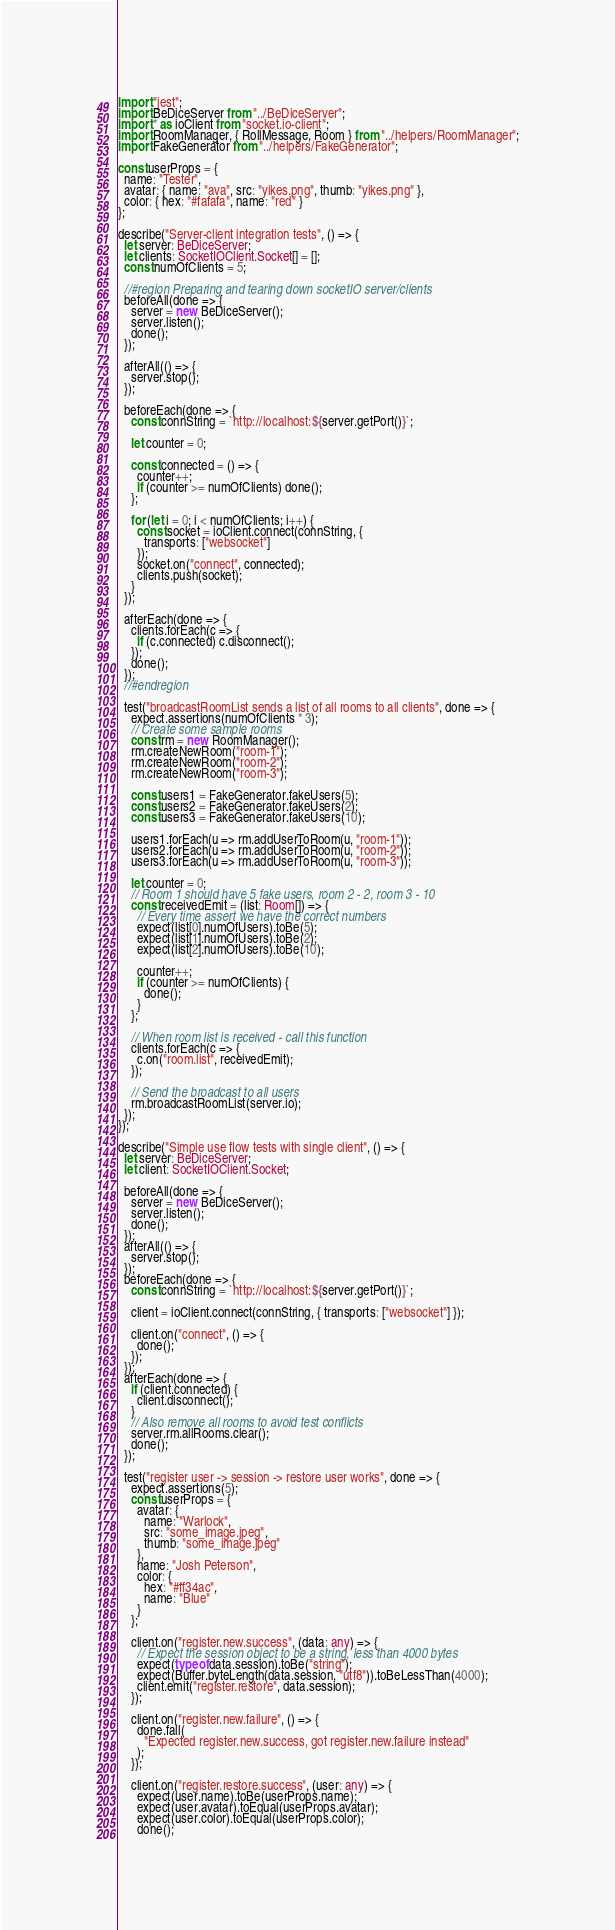<code> <loc_0><loc_0><loc_500><loc_500><_TypeScript_>import "jest";
import BeDiceServer from "../BeDiceServer";
import * as ioClient from "socket.io-client";
import RoomManager, { RollMessage, Room } from "../helpers/RoomManager";
import FakeGenerator from "../helpers/FakeGenerator";

const userProps = {
  name: "Tester",
  avatar: { name: "ava", src: "yikes.png", thumb: "yikes.png" },
  color: { hex: "#fafafa", name: "red" }
};

describe("Server-client integration tests", () => {
  let server: BeDiceServer;
  let clients: SocketIOClient.Socket[] = [];
  const numOfClients = 5;

  //#region Preparing and tearing down socketIO server/clients
  beforeAll(done => {
    server = new BeDiceServer();
    server.listen();
    done();
  });

  afterAll(() => {
    server.stop();
  });

  beforeEach(done => {
    const connString = `http://localhost:${server.getPort()}`;

    let counter = 0;

    const connected = () => {
      counter++;
      if (counter >= numOfClients) done();
    };

    for (let i = 0; i < numOfClients; i++) {
      const socket = ioClient.connect(connString, {
        transports: ["websocket"]
      });
      socket.on("connect", connected);
      clients.push(socket);
    }
  });

  afterEach(done => {
    clients.forEach(c => {
      if (c.connected) c.disconnect();
    });
    done();
  });
  //#endregion

  test("broadcastRoomList sends a list of all rooms to all clients", done => {
    expect.assertions(numOfClients * 3);
    // Create some sample rooms
    const rm = new RoomManager();
    rm.createNewRoom("room-1");
    rm.createNewRoom("room-2");
    rm.createNewRoom("room-3");

    const users1 = FakeGenerator.fakeUsers(5);
    const users2 = FakeGenerator.fakeUsers(2);
    const users3 = FakeGenerator.fakeUsers(10);

    users1.forEach(u => rm.addUserToRoom(u, "room-1"));
    users2.forEach(u => rm.addUserToRoom(u, "room-2"));
    users3.forEach(u => rm.addUserToRoom(u, "room-3"));

    let counter = 0;
    // Room 1 should have 5 fake users, room 2 - 2, room 3 - 10
    const receivedEmit = (list: Room[]) => {
      // Every time assert we have the correct numbers
      expect(list[0].numOfUsers).toBe(5);
      expect(list[1].numOfUsers).toBe(2);
      expect(list[2].numOfUsers).toBe(10);

      counter++;
      if (counter >= numOfClients) {
        done();
      }
    };

    // When room list is received - call this function
    clients.forEach(c => {
      c.on("room.list", receivedEmit);
    });

    // Send the broadcast to all users
    rm.broadcastRoomList(server.io);
  });
});

describe("Simple use flow tests with single client", () => {
  let server: BeDiceServer;
  let client: SocketIOClient.Socket;

  beforeAll(done => {
    server = new BeDiceServer();
    server.listen();
    done();
  });
  afterAll(() => {
    server.stop();
  });
  beforeEach(done => {
    const connString = `http://localhost:${server.getPort()}`;

    client = ioClient.connect(connString, { transports: ["websocket"] });

    client.on("connect", () => {
      done();
    });
  });
  afterEach(done => {
    if (client.connected) {
      client.disconnect();
    }
    // Also remove all rooms to avoid test conflicts
    server.rm.allRooms.clear();
    done();
  });

  test("register user -> session -> restore user works", done => {
    expect.assertions(5);
    const userProps = {
      avatar: {
        name: "Warlock",
        src: "some_image.jpeg",
        thumb: "some_image.jpeg"
      },
      name: "Josh Peterson",
      color: {
        hex: "#ff34ac",
        name: "Blue"
      }
    };

    client.on("register.new.success", (data: any) => {
      // Expect the session object to be a string, less than 4000 bytes
      expect(typeof data.session).toBe("string");
      expect(Buffer.byteLength(data.session, "utf8")).toBeLessThan(4000);
      client.emit("register.restore", data.session);
    });

    client.on("register.new.failure", () => {
      done.fail(
        "Expected register.new.success, got register.new.failure instead"
      );
    });

    client.on("register.restore.success", (user: any) => {
      expect(user.name).toBe(userProps.name);
      expect(user.avatar).toEqual(userProps.avatar);
      expect(user.color).toEqual(userProps.color);
      done();</code> 